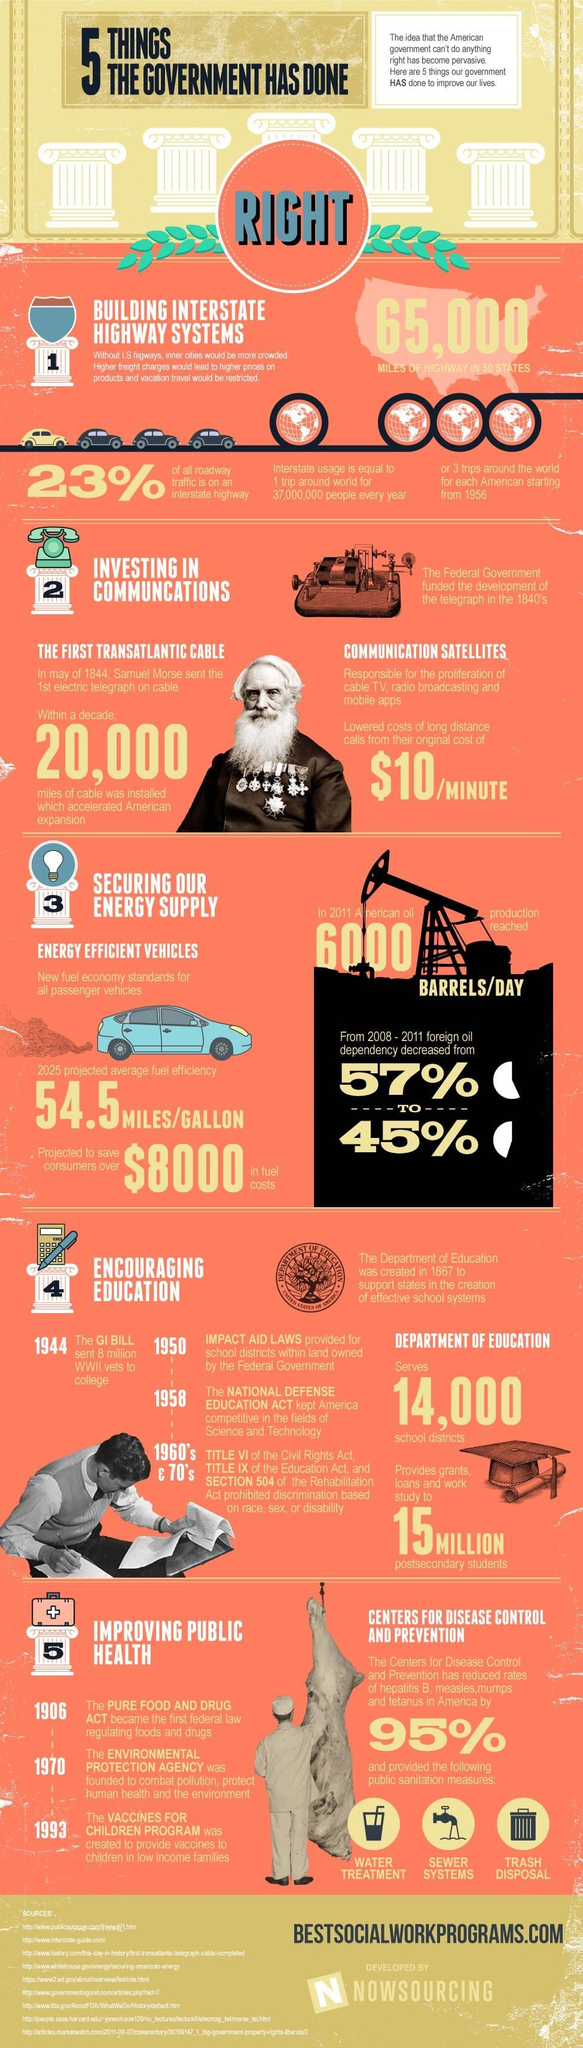How many years after the Envrironmental protection agency was founded was the vaccine for children program created
Answer the question with a short phrase. 23 How many miles of highway has been constructed 65,000 What has been the % decrease in foreign oil dependency from 2008 - 2001 12 What was the initial cost of long distance calls $10/minute What are the public sanitation measures provided by the centres for disease control and prevention water treatment, sewer systems, trash disposal Who introduced telegraph Samuel Morse What is the dependency on foreign oil in 2011 45% 